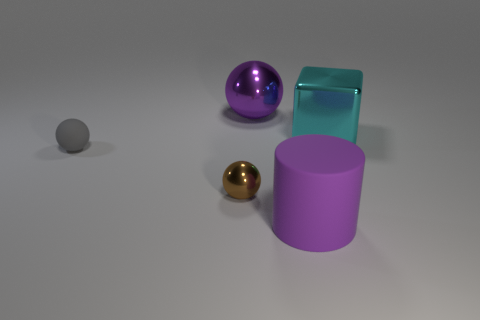There is a shiny thing that is the same color as the rubber cylinder; what size is it?
Your answer should be compact. Large. How many large objects are the same color as the big ball?
Keep it short and to the point. 1. The rubber thing that is right of the large shiny ball that is behind the brown sphere is what shape?
Keep it short and to the point. Cylinder. Does the cylinder have the same color as the metallic sphere that is behind the small brown object?
Make the answer very short. Yes. There is a thing that is both left of the big cyan metal block and behind the gray rubber object; what is it made of?
Your answer should be very brief. Metal. How many other objects are the same color as the large matte cylinder?
Offer a terse response. 1. Are the gray sphere and the big purple ball made of the same material?
Your response must be concise. No. What material is the object that is the same size as the rubber sphere?
Your answer should be very brief. Metal. What is the material of the ball that is the same color as the rubber cylinder?
Provide a succinct answer. Metal. There is another tiny object that is the same material as the cyan object; what color is it?
Your response must be concise. Brown. 